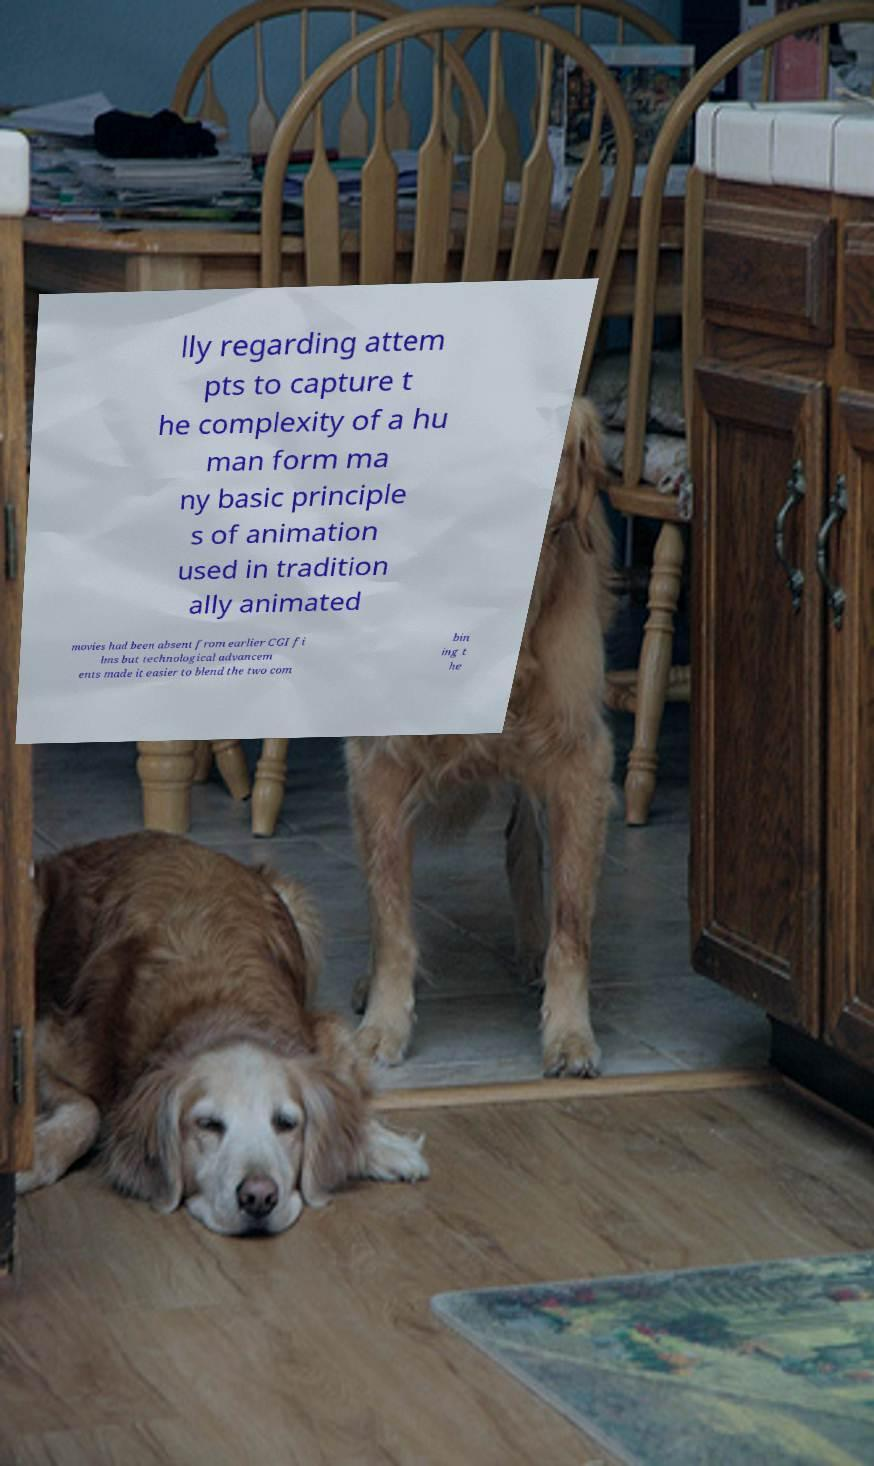Please identify and transcribe the text found in this image. lly regarding attem pts to capture t he complexity of a hu man form ma ny basic principle s of animation used in tradition ally animated movies had been absent from earlier CGI fi lms but technological advancem ents made it easier to blend the two com bin ing t he 